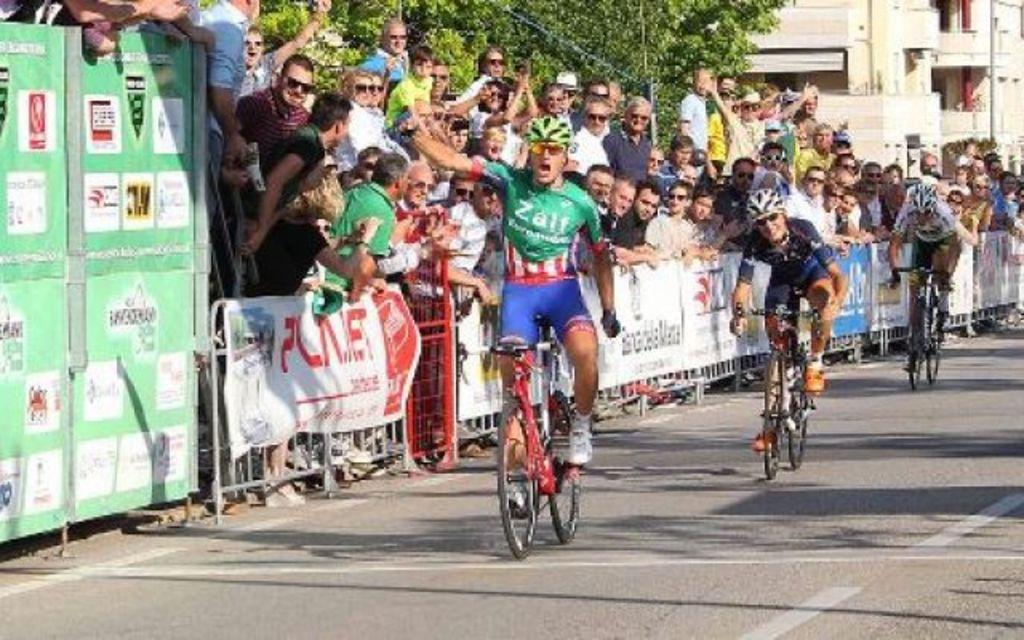<image>
Describe the image concisely. some bikers racing with one guy wearing green and the word Zalf on it 